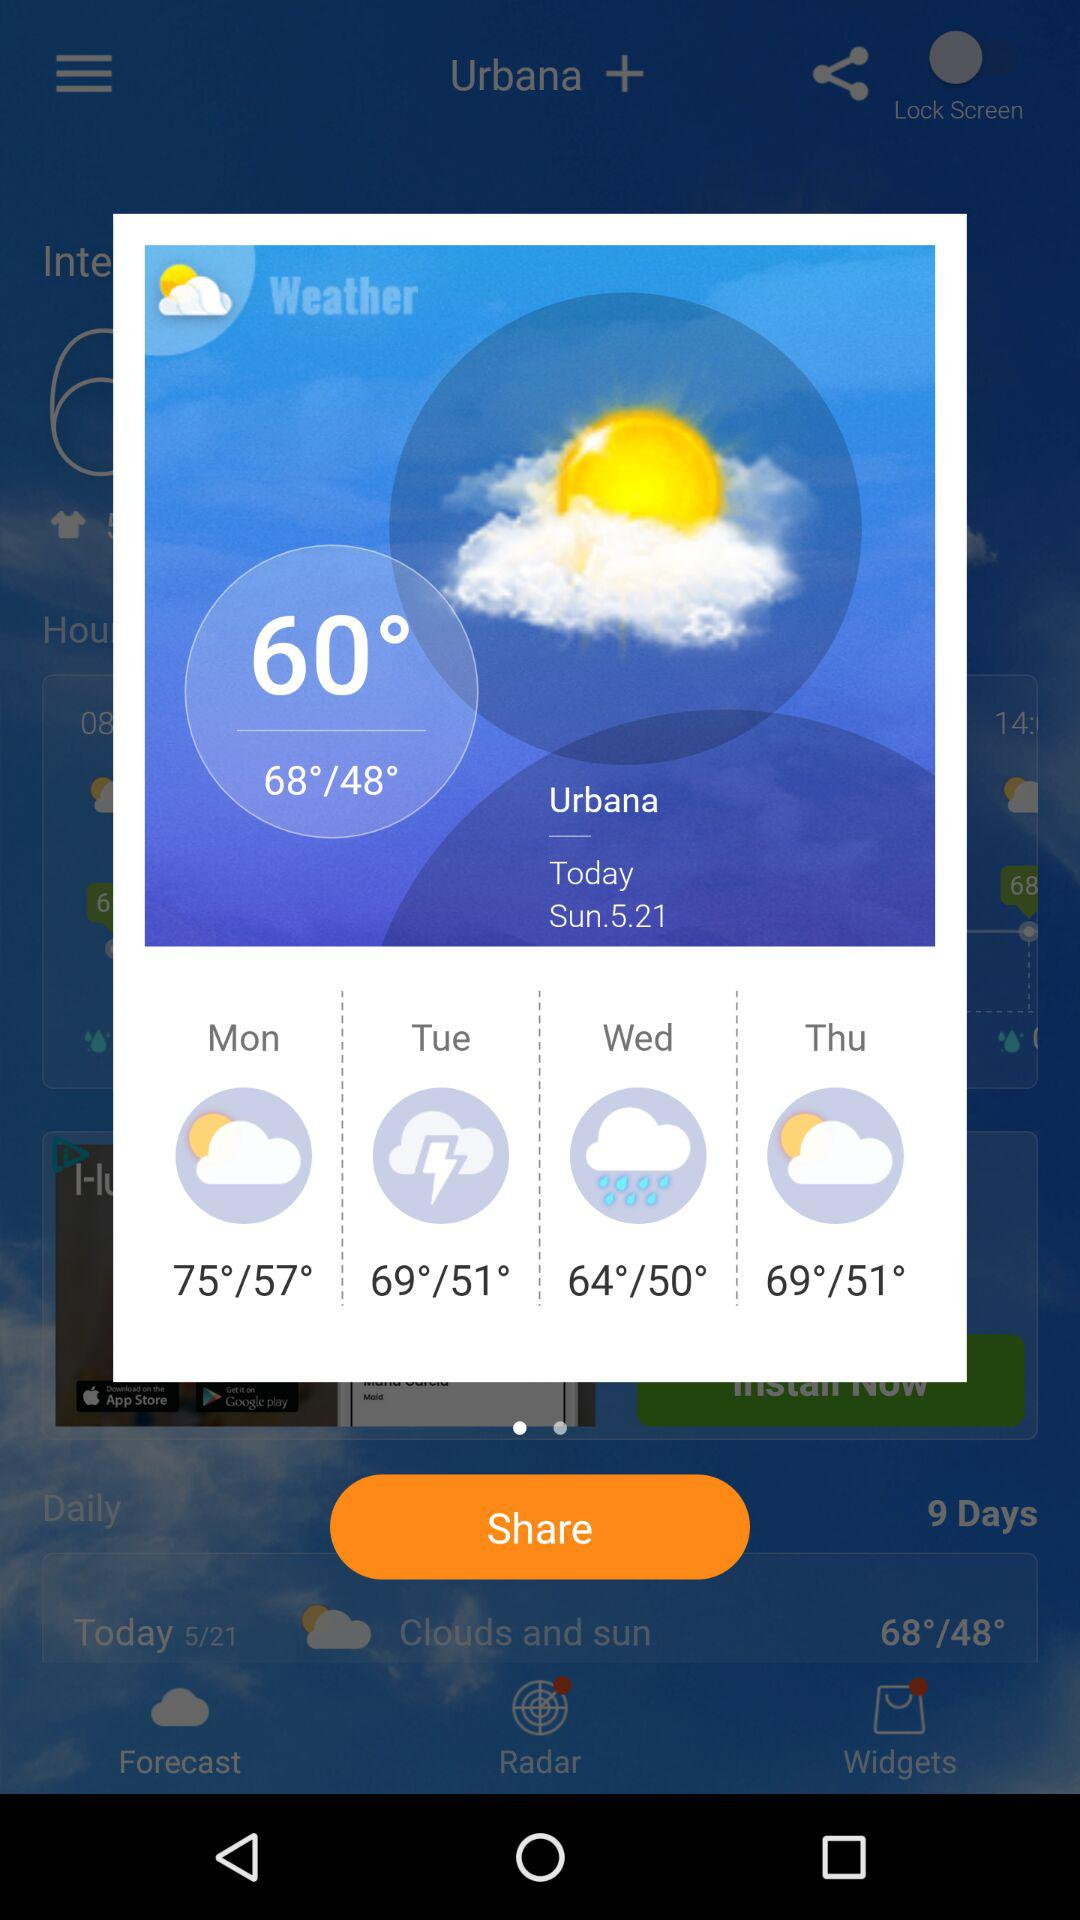What is the date today? The date is Sunday, 21st May. 